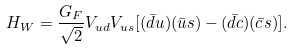<formula> <loc_0><loc_0><loc_500><loc_500>H _ { W } = { \frac { G _ { F } } { \sqrt { 2 } } } V _ { u d } V _ { u s } [ ( \bar { d } u ) ( \bar { u } s ) - ( \bar { d } c ) ( \bar { c } s ) ] .</formula> 